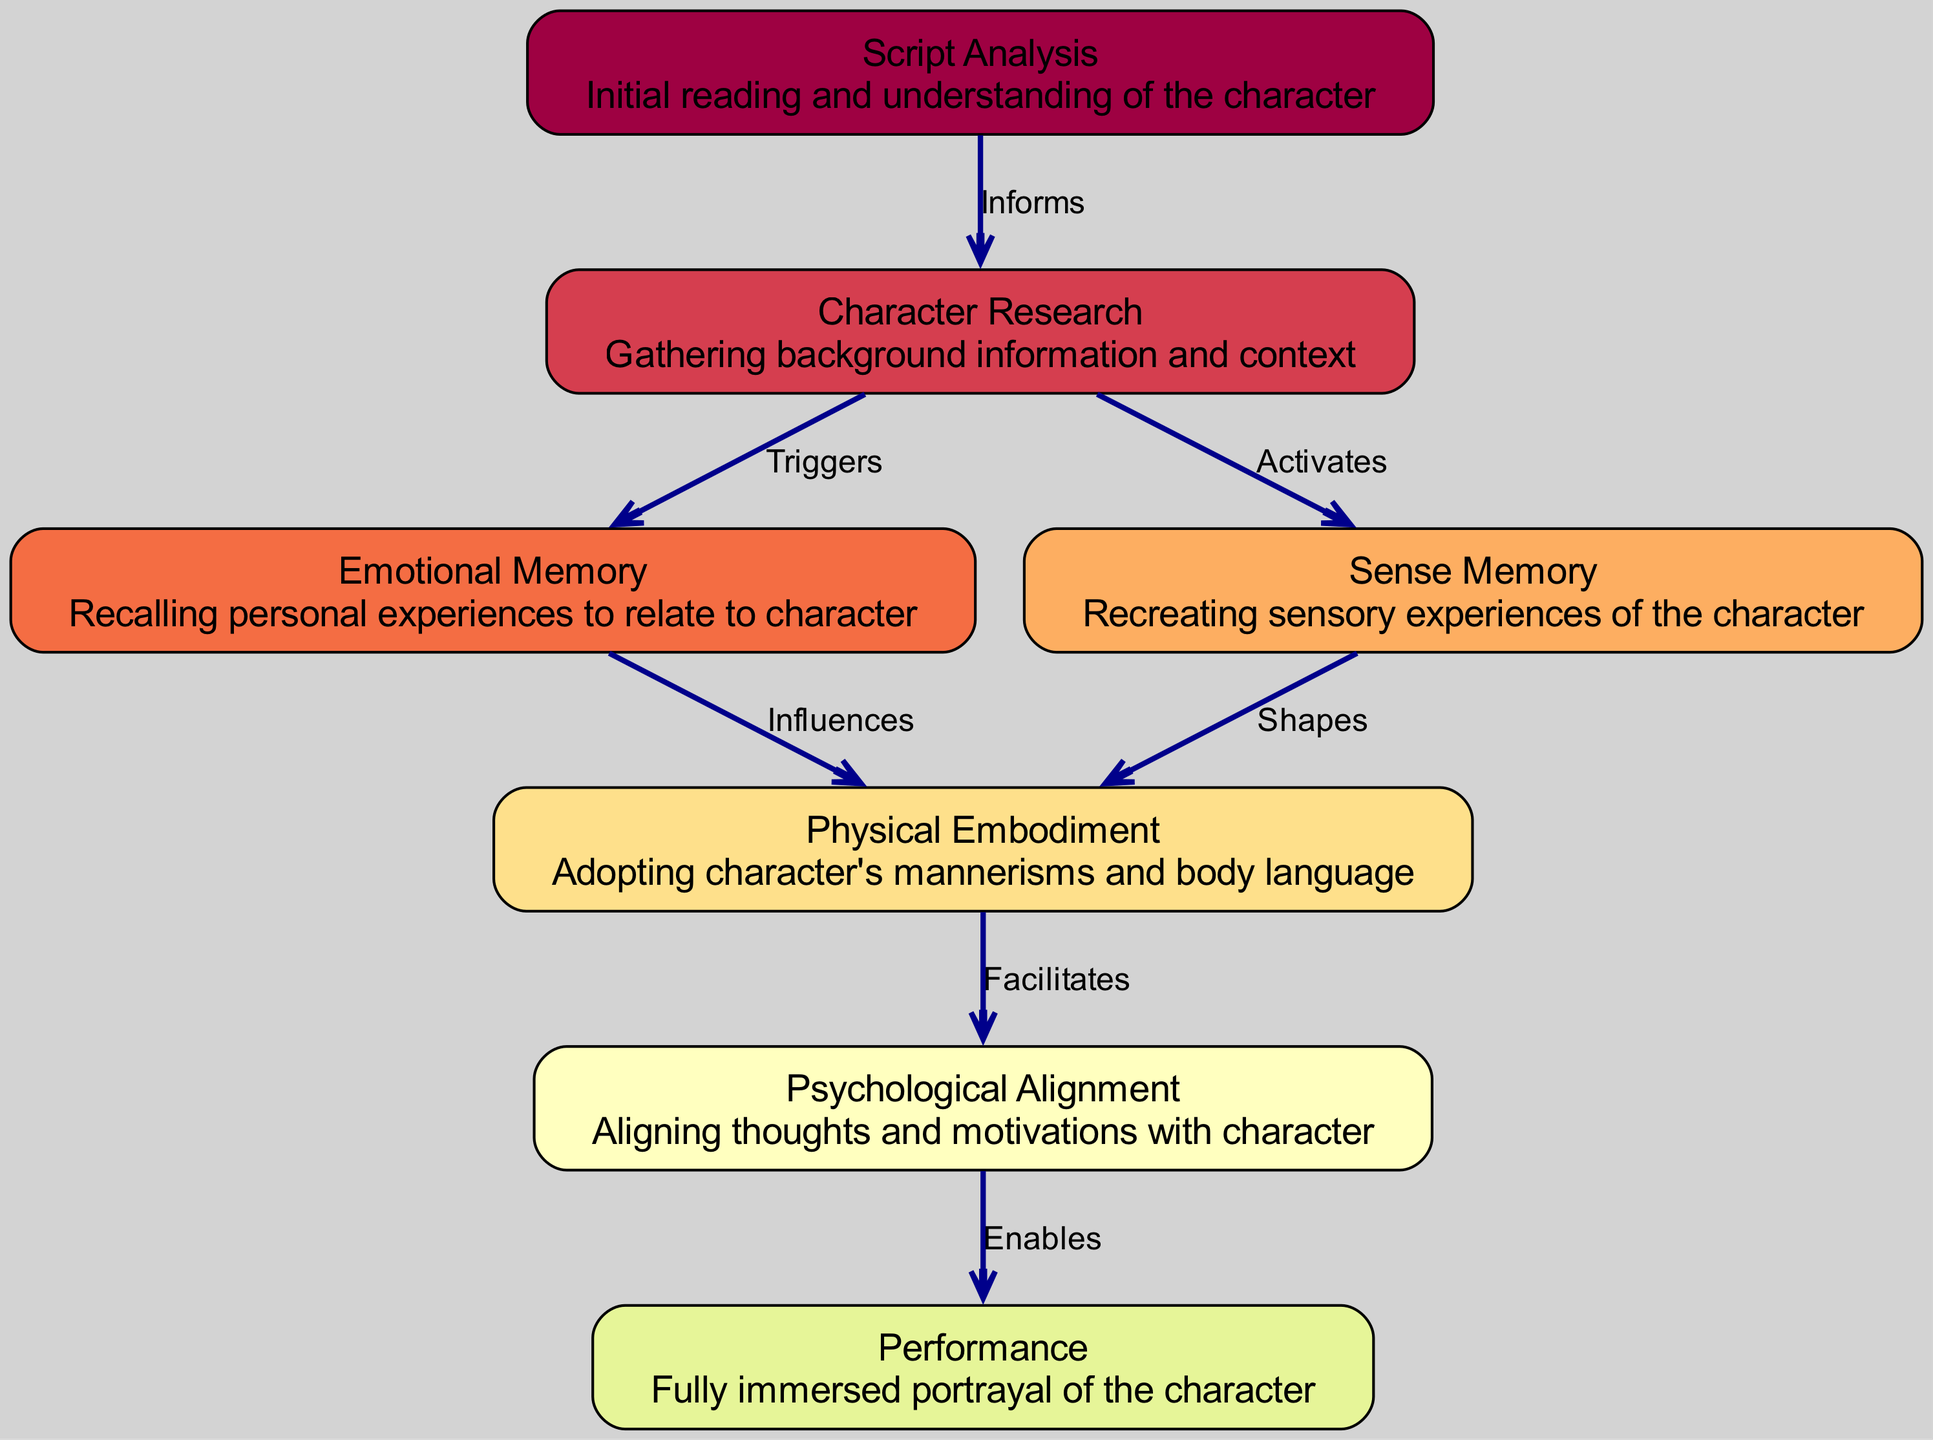What is the first step in the character immersion process? The first step in the process is "Script Analysis," which is indicated as the starting point of the flowchart and represents the initial reading and understanding of the character.
Answer: Script Analysis How many nodes are present in the diagram? The diagram features a total of seven nodes that represent different psychological processes involved in character immersion, as listed in the nodes section.
Answer: Seven What does "Character Research" trigger? "Character Research" triggers "Emotional Memory," as indicated by the directed edge labeled "Triggers," showing that gathering background information allows actors to recall personal experiences.
Answer: Emotional Memory What relationship does "Sense Memory" have with "Physical Embodiment"? "Sense Memory" shapes "Physical Embodiment," as shown in the diagram by the directed edge labeled "Shapes," indicating that recreating sensory experiences influences how the character's mannerisms are adopted.
Answer: Shapes Which step facilitates the process of "Psychological Alignment"? "Physical Embodiment" facilitates the process of "Psychological Alignment," as indicated by the edge labeled "Facilitates," meaning that adopting the character's mannerisms helps align thoughts and motivations with that character.
Answer: Physical Embodiment How many edges connect the nodes in the diagram? The diagram contains a total of six edges, which show the connections and relationships between the seven nodes representing psychological processes.
Answer: Six What enables the "Performance" of the character? "Psychological Alignment" enables the "Performance" of the character, as shown by the edge labeled "Enables," indicating that aligning one's thoughts and motivations with the character is crucial for a fully immersed portrayal.
Answer: Psychological Alignment What does "Script Analysis" inform? "Script Analysis" informs "Character Research," as indicated by the edge labeled "Informs," showing that understanding the character is foundational for gathering background information and context.
Answer: Character Research Which node is influenced by "Emotional Memory"? "Physical Embodiment" is influenced by "Emotional Memory," as indicated by the directed edge labeled "Influences." This shows that recalling personal experiences has an effect on how the character's mannerisms and body language are adopted.
Answer: Physical Embodiment 